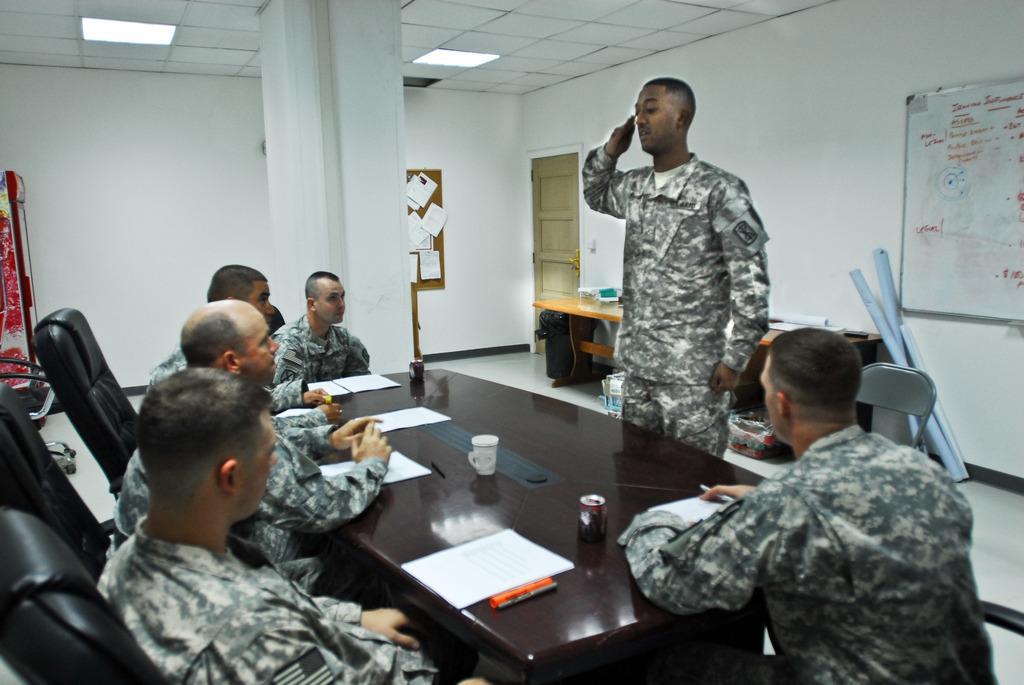Please provide a concise description of this image. In this image I can see few people sitting on chairs and wearing military dresses. In front one person is standing. I can see a cup,tin,papers and few objects on the table. Back I can see a door,boards,chart papers and a white wall. 